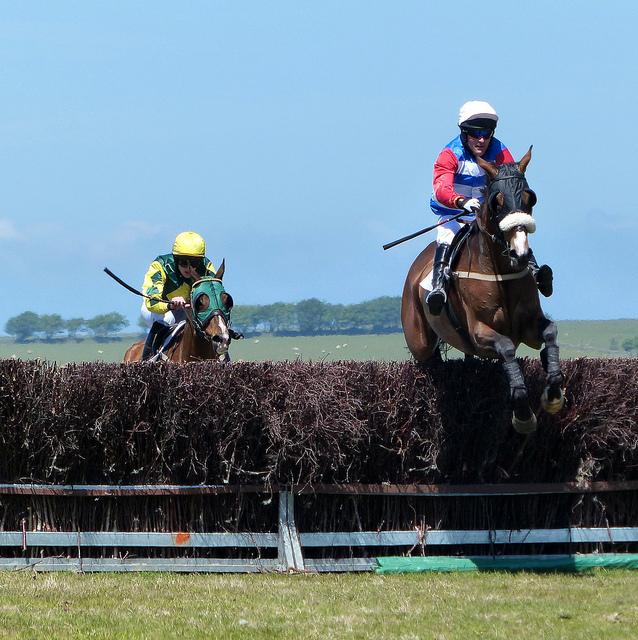According to Mother Goose is there a nimble fellow named Jack that does what these animals do?
Concise answer only. Yes. Are both horses jumping?
Answer briefly. No. Is this on a race track?
Quick response, please. No. 